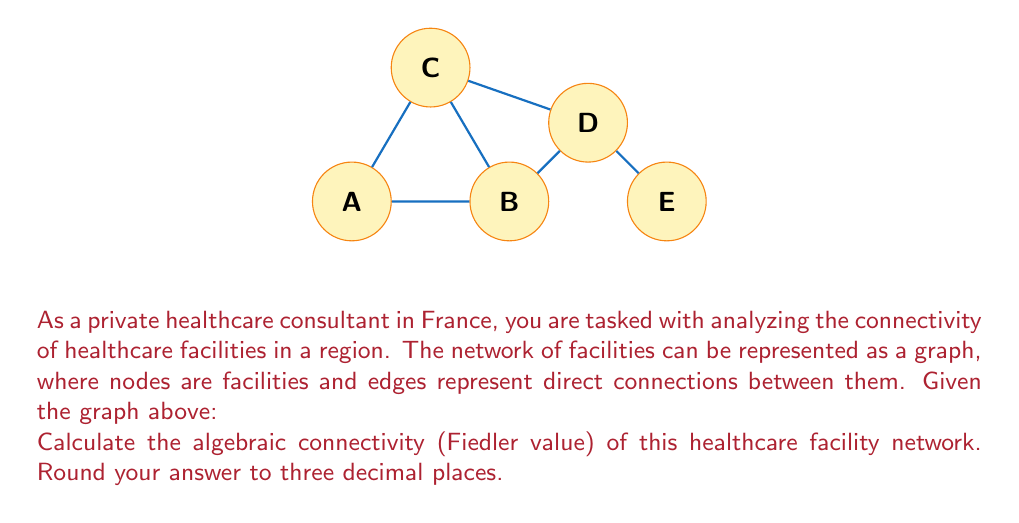What is the answer to this math problem? To find the algebraic connectivity (Fiedler value) of the graph, we need to follow these steps:

1) First, construct the Laplacian matrix $L$ of the graph. The Laplacian matrix is defined as $L = D - A$, where $D$ is the degree matrix and $A$ is the adjacency matrix.

2) The adjacency matrix $A$ for this graph is:
   $$A = \begin{bmatrix}
   0 & 1 & 1 & 0 & 0\\
   1 & 0 & 1 & 1 & 0\\
   1 & 1 & 0 & 1 & 0\\
   0 & 1 & 1 & 0 & 1\\
   0 & 0 & 0 & 1 & 0
   \end{bmatrix}$$

3) The degree matrix $D$ is:
   $$D = \begin{bmatrix}
   2 & 0 & 0 & 0 & 0\\
   0 & 3 & 0 & 0 & 0\\
   0 & 0 & 3 & 0 & 0\\
   0 & 0 & 0 & 3 & 0\\
   0 & 0 & 0 & 0 & 1
   \end{bmatrix}$$

4) The Laplacian matrix $L = D - A$ is:
   $$L = \begin{bmatrix}
   2 & -1 & -1 & 0 & 0\\
   -1 & 3 & -1 & -1 & 0\\
   -1 & -1 & 3 & -1 & 0\\
   0 & -1 & -1 & 3 & -1\\
   0 & 0 & 0 & -1 & 1
   \end{bmatrix}$$

5) Calculate the eigenvalues of $L$. The characteristic equation is:
   $$det(L - \lambda I) = 0$$

6) Solving this equation (which can be done using computer algebra systems), we get the eigenvalues:
   $\lambda_1 = 0$
   $\lambda_2 \approx 0.5188$
   $\lambda_3 \approx 2.0000$
   $\lambda_4 \approx 3.3234$
   $\lambda_5 \approx 4.1578$

7) The algebraic connectivity (Fiedler value) is the second smallest eigenvalue, which is $\lambda_2 \approx 0.5188$.

8) Rounding to three decimal places, we get 0.519.

This value indicates the level of connectivity in the network. A higher value suggests better connectivity and robustness against node/edge failures.
Answer: 0.519 